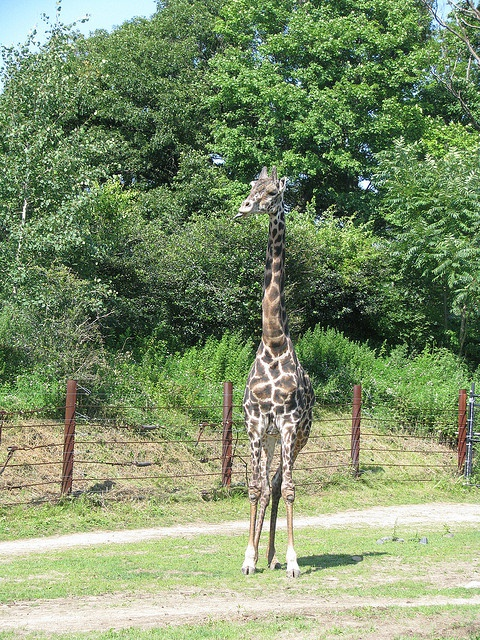Describe the objects in this image and their specific colors. I can see a giraffe in lightblue, gray, white, darkgray, and black tones in this image. 